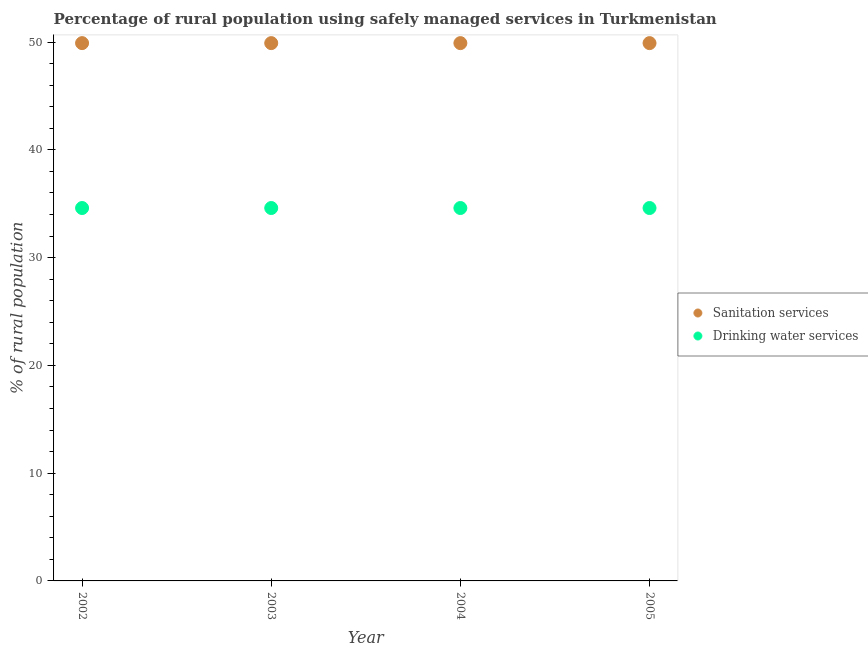How many different coloured dotlines are there?
Provide a short and direct response. 2. Is the number of dotlines equal to the number of legend labels?
Your answer should be compact. Yes. What is the percentage of rural population who used drinking water services in 2003?
Offer a terse response. 34.6. Across all years, what is the maximum percentage of rural population who used drinking water services?
Your answer should be very brief. 34.6. Across all years, what is the minimum percentage of rural population who used sanitation services?
Provide a succinct answer. 49.9. What is the total percentage of rural population who used sanitation services in the graph?
Make the answer very short. 199.6. What is the difference between the percentage of rural population who used sanitation services in 2002 and the percentage of rural population who used drinking water services in 2005?
Offer a very short reply. 15.3. What is the average percentage of rural population who used drinking water services per year?
Offer a terse response. 34.6. In the year 2002, what is the difference between the percentage of rural population who used sanitation services and percentage of rural population who used drinking water services?
Make the answer very short. 15.3. What is the ratio of the percentage of rural population who used drinking water services in 2003 to that in 2004?
Make the answer very short. 1. What is the difference between the highest and the second highest percentage of rural population who used sanitation services?
Your answer should be compact. 0. In how many years, is the percentage of rural population who used drinking water services greater than the average percentage of rural population who used drinking water services taken over all years?
Ensure brevity in your answer.  0. Is the sum of the percentage of rural population who used drinking water services in 2002 and 2004 greater than the maximum percentage of rural population who used sanitation services across all years?
Give a very brief answer. Yes. Is the percentage of rural population who used sanitation services strictly greater than the percentage of rural population who used drinking water services over the years?
Provide a short and direct response. Yes. How many dotlines are there?
Offer a very short reply. 2. How many years are there in the graph?
Your response must be concise. 4. What is the difference between two consecutive major ticks on the Y-axis?
Your answer should be very brief. 10. Does the graph contain grids?
Ensure brevity in your answer.  No. Where does the legend appear in the graph?
Make the answer very short. Center right. How many legend labels are there?
Keep it short and to the point. 2. What is the title of the graph?
Your answer should be compact. Percentage of rural population using safely managed services in Turkmenistan. Does "Diesel" appear as one of the legend labels in the graph?
Ensure brevity in your answer.  No. What is the label or title of the Y-axis?
Give a very brief answer. % of rural population. What is the % of rural population in Sanitation services in 2002?
Your response must be concise. 49.9. What is the % of rural population in Drinking water services in 2002?
Ensure brevity in your answer.  34.6. What is the % of rural population of Sanitation services in 2003?
Provide a short and direct response. 49.9. What is the % of rural population of Drinking water services in 2003?
Your response must be concise. 34.6. What is the % of rural population of Sanitation services in 2004?
Offer a very short reply. 49.9. What is the % of rural population in Drinking water services in 2004?
Offer a terse response. 34.6. What is the % of rural population in Sanitation services in 2005?
Provide a succinct answer. 49.9. What is the % of rural population of Drinking water services in 2005?
Offer a very short reply. 34.6. Across all years, what is the maximum % of rural population in Sanitation services?
Offer a very short reply. 49.9. Across all years, what is the maximum % of rural population of Drinking water services?
Give a very brief answer. 34.6. Across all years, what is the minimum % of rural population in Sanitation services?
Your response must be concise. 49.9. Across all years, what is the minimum % of rural population in Drinking water services?
Ensure brevity in your answer.  34.6. What is the total % of rural population in Sanitation services in the graph?
Offer a very short reply. 199.6. What is the total % of rural population of Drinking water services in the graph?
Your answer should be compact. 138.4. What is the difference between the % of rural population in Drinking water services in 2002 and that in 2005?
Ensure brevity in your answer.  0. What is the difference between the % of rural population in Sanitation services in 2003 and that in 2004?
Your answer should be very brief. 0. What is the difference between the % of rural population in Sanitation services in 2004 and that in 2005?
Provide a succinct answer. 0. What is the difference between the % of rural population in Sanitation services in 2003 and the % of rural population in Drinking water services in 2004?
Offer a very short reply. 15.3. What is the difference between the % of rural population of Sanitation services in 2003 and the % of rural population of Drinking water services in 2005?
Your answer should be compact. 15.3. What is the average % of rural population of Sanitation services per year?
Your response must be concise. 49.9. What is the average % of rural population of Drinking water services per year?
Offer a terse response. 34.6. In the year 2005, what is the difference between the % of rural population of Sanitation services and % of rural population of Drinking water services?
Provide a short and direct response. 15.3. What is the ratio of the % of rural population in Drinking water services in 2002 to that in 2003?
Offer a terse response. 1. What is the ratio of the % of rural population in Sanitation services in 2002 to that in 2005?
Your response must be concise. 1. What is the ratio of the % of rural population of Sanitation services in 2003 to that in 2005?
Your answer should be very brief. 1. What is the difference between the highest and the lowest % of rural population of Sanitation services?
Your answer should be compact. 0. What is the difference between the highest and the lowest % of rural population of Drinking water services?
Provide a succinct answer. 0. 